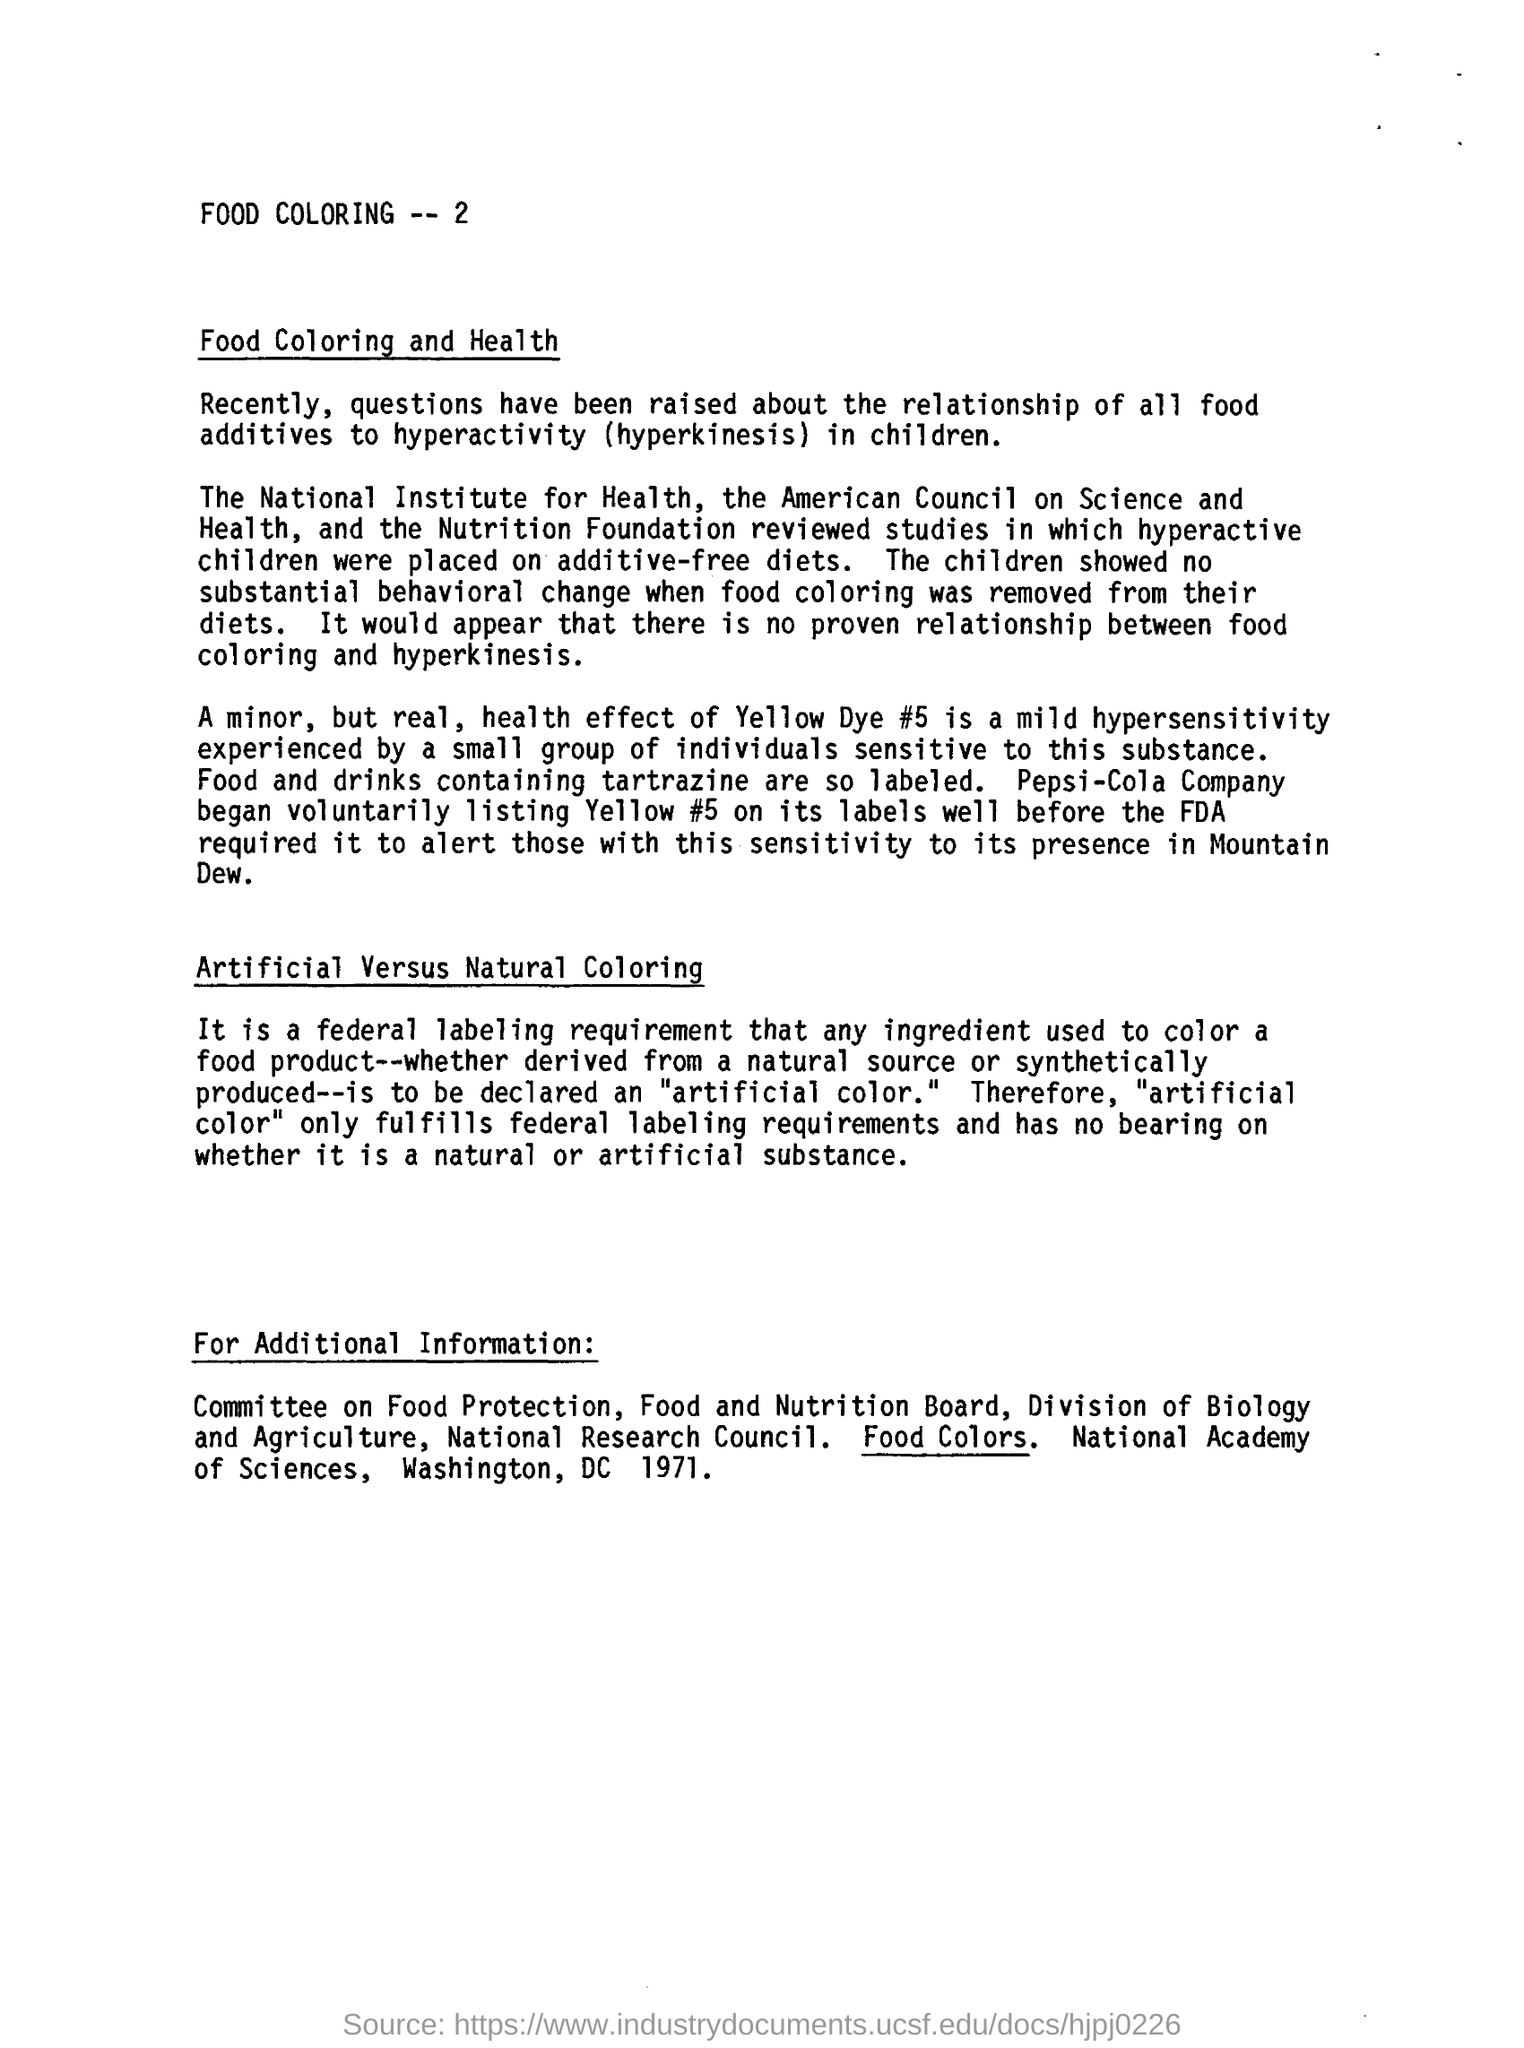Who began voluntarily listing yello #5 on its labels well before the fda required
Your response must be concise. Pepsi-Cola Company. Artificial colour only fulfils whose labelling requirements
Give a very brief answer. Federal labeling requirements. What was removed from the diets of hyperactive children as part of the study?
Your answer should be compact. Food coloring. 